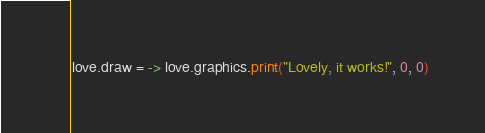Convert code to text. <code><loc_0><loc_0><loc_500><loc_500><_MoonScript_>love.draw = -> love.graphics.print("Lovely, it works!", 0, 0)</code> 